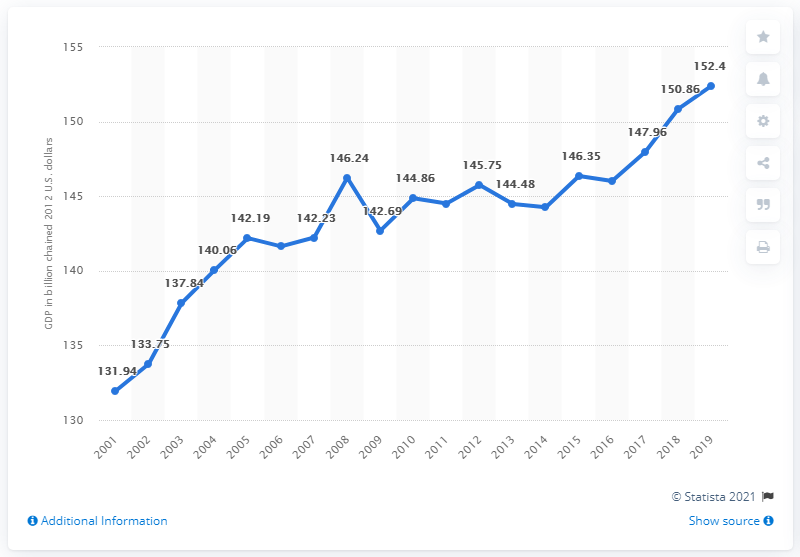Highlight a few significant elements in this photo. In 2012, the GDP of the St. Louis metro area was 152.4 billion dollars, when adjusted for inflation. 